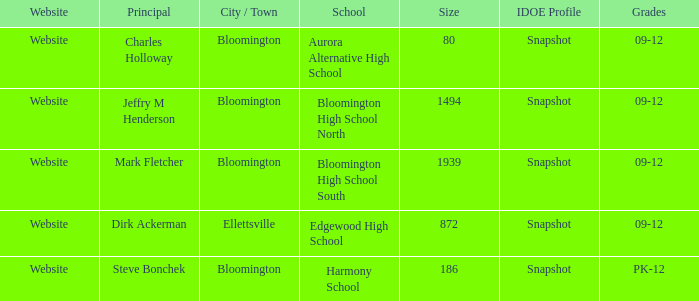Who's the principal of Edgewood High School?/ Dirk Ackerman. 